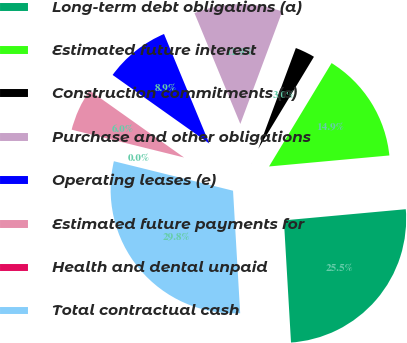Convert chart. <chart><loc_0><loc_0><loc_500><loc_500><pie_chart><fcel>Long-term debt obligations (a)<fcel>Estimated future interest<fcel>Construction commitments (c)<fcel>Purchase and other obligations<fcel>Operating leases (e)<fcel>Estimated future payments for<fcel>Health and dental unpaid<fcel>Total contractual cash<nl><fcel>25.53%<fcel>14.89%<fcel>2.98%<fcel>11.92%<fcel>8.94%<fcel>5.96%<fcel>0.0%<fcel>29.79%<nl></chart> 